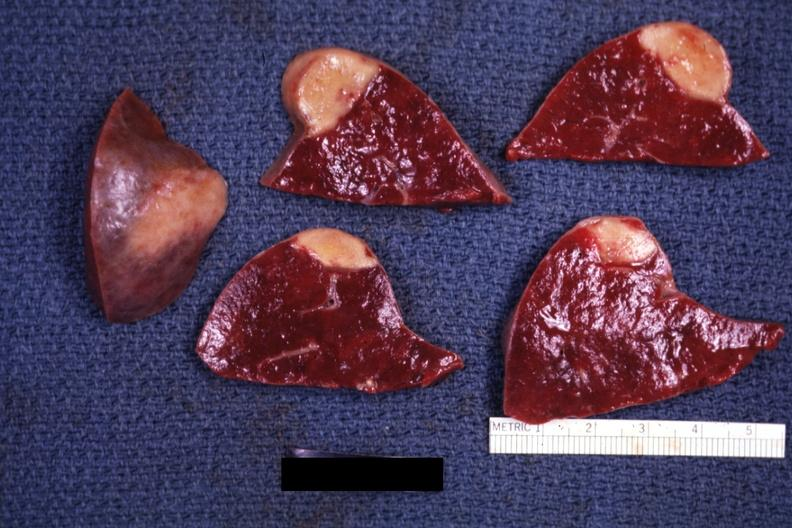s glomerulosa present?
Answer the question using a single word or phrase. No 